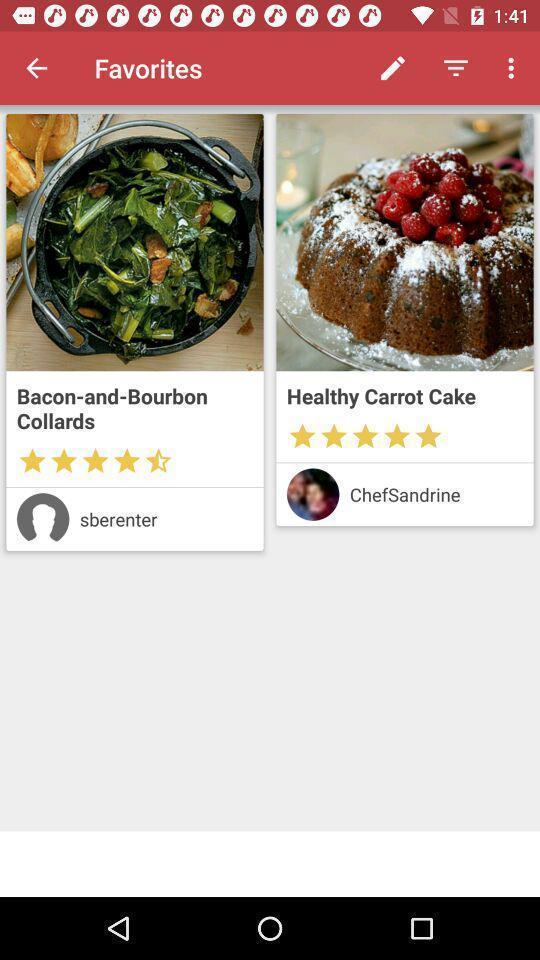Describe the visual elements of this screenshot. Page showing favorites in a recipes app. 